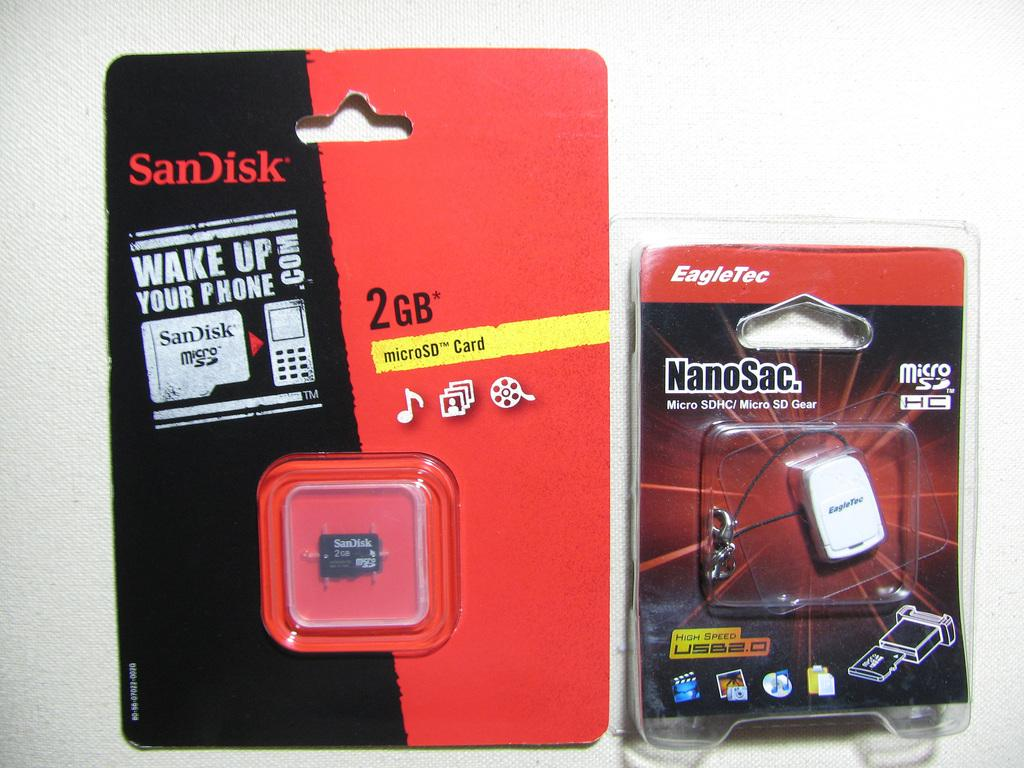Provide a one-sentence caption for the provided image. micro memory card for mobile device two gigs. 